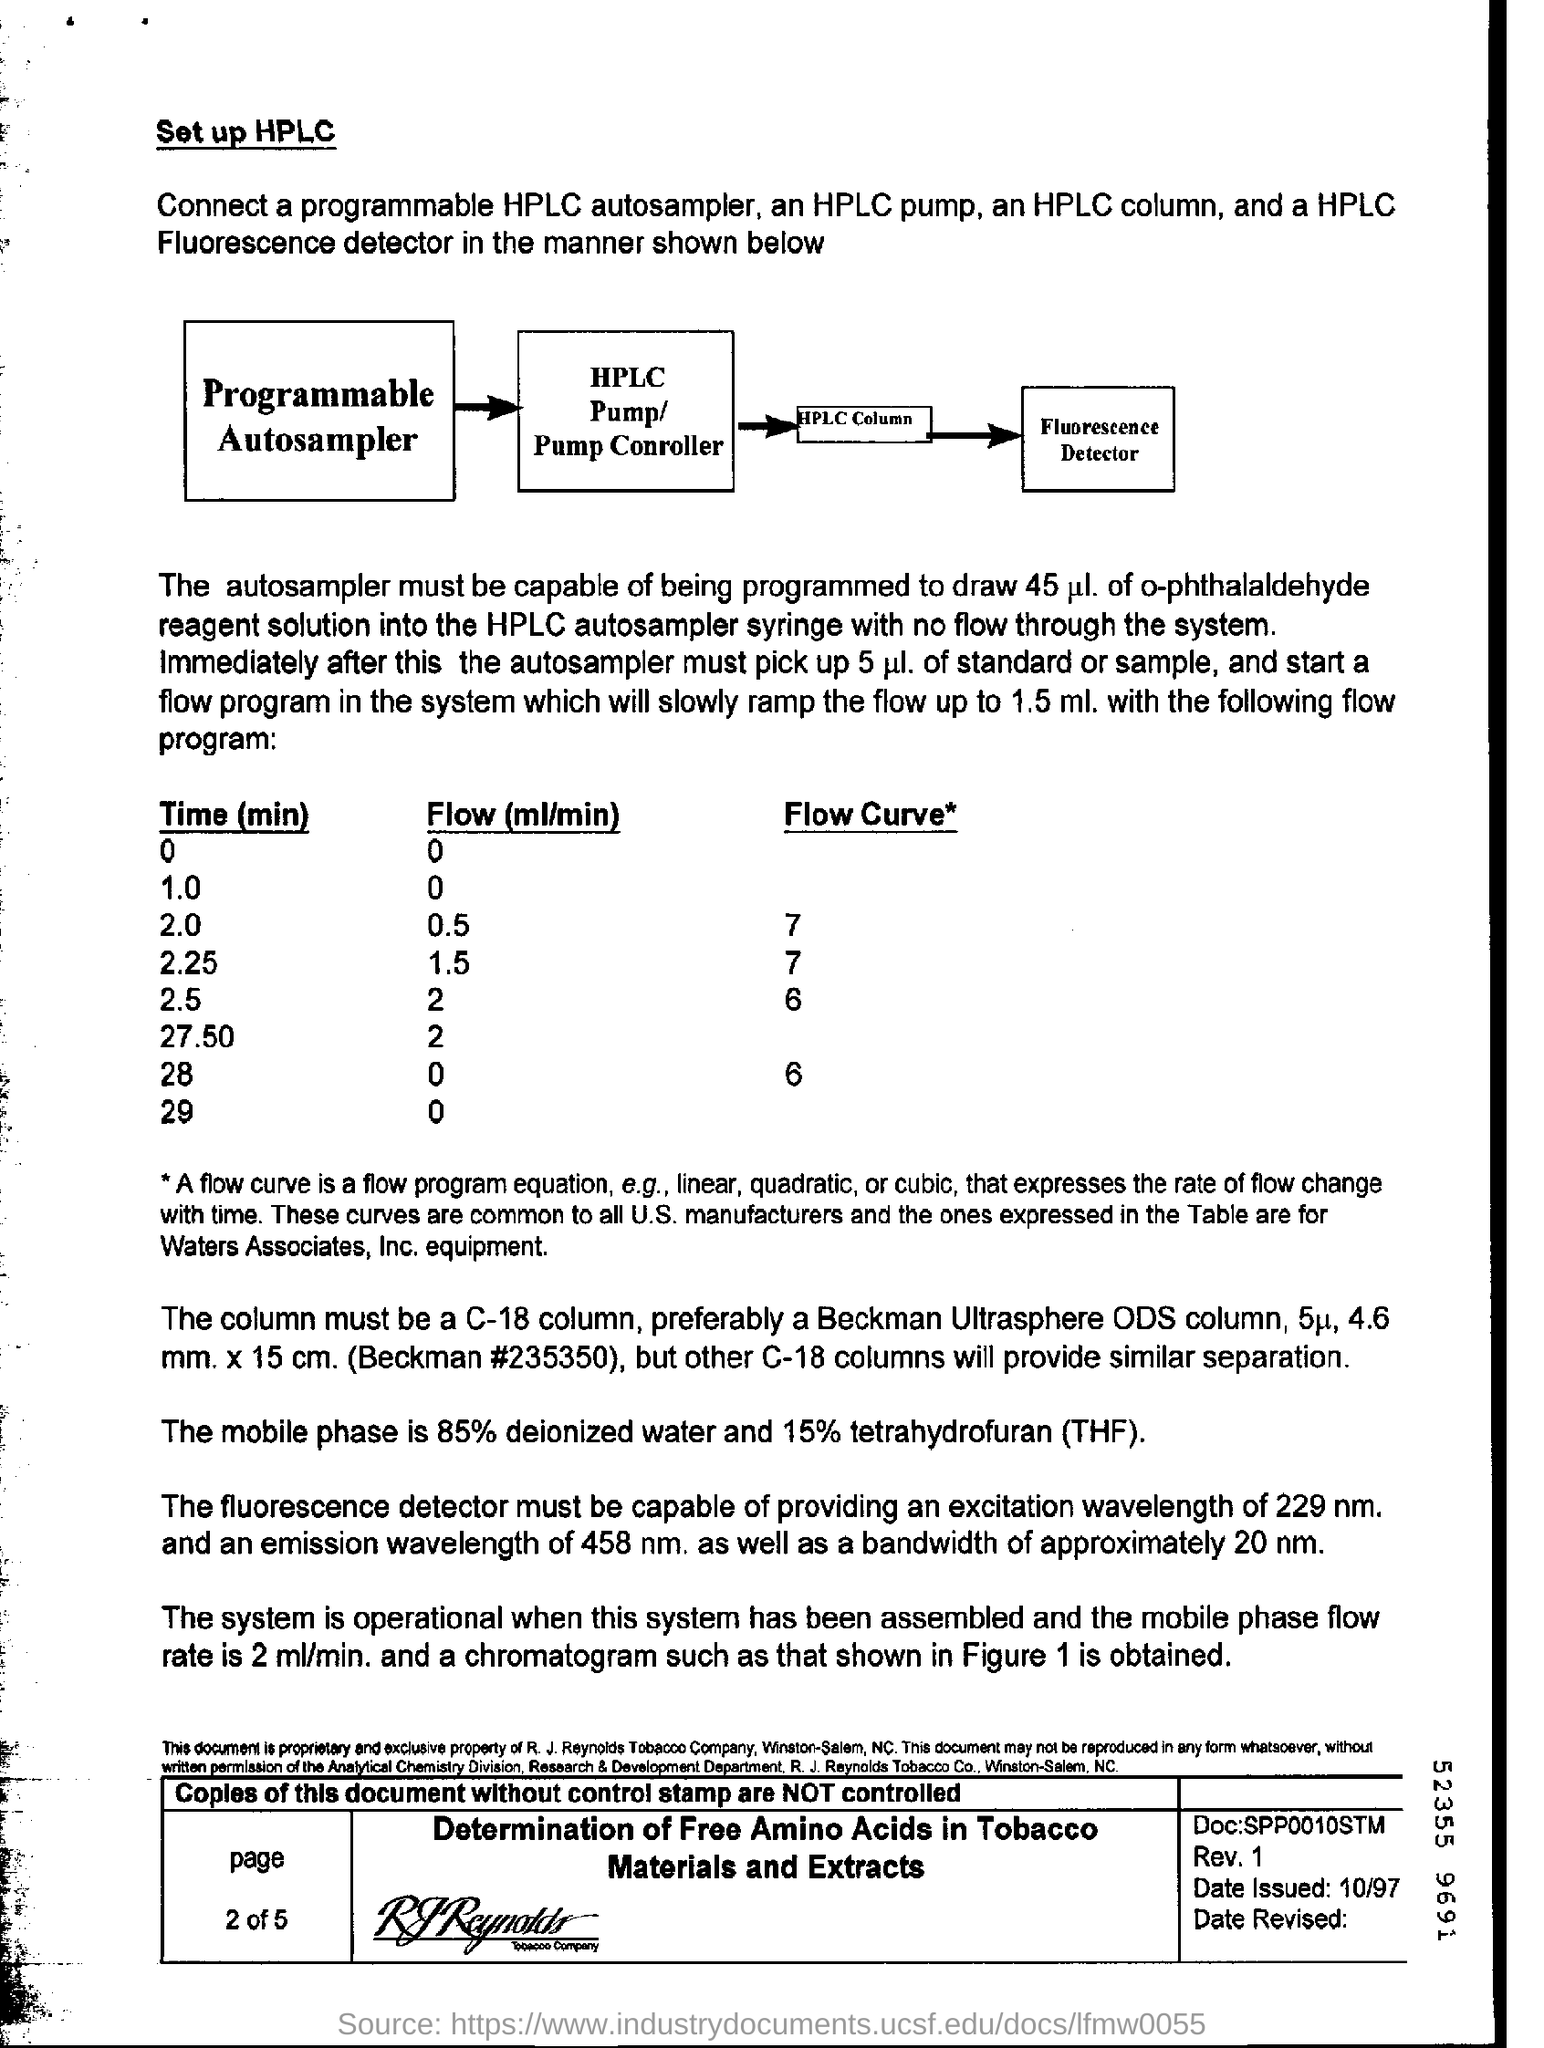What is the date issued?
Provide a short and direct response. 10/97. What is the percentage of tetrahydrofuran in the mobile phase?
Keep it short and to the point. 15%. What is the percentage of deionized water in the mobile phase?
Your answer should be compact. 85. What is the Flow (ml/min) for time (min) 1.0?
Provide a short and direct response. 0. What is the Flow (ml/min) for time (min) 2.0?
Keep it short and to the point. 0.5. What is the Flow (ml/min) for time (min) 2.25?
Provide a short and direct response. 1.5. What is the Flow (ml/min) for time (min) 2.5?
Keep it short and to the point. 2. What is the Flow (ml/min) for time (min) 27.50?
Offer a terse response. 2. What is the Flow (ml/min) for time (min) 28?
Offer a terse response. 0. What is the Flow (ml/min) for time (min) 29?
Keep it short and to the point. 0. 